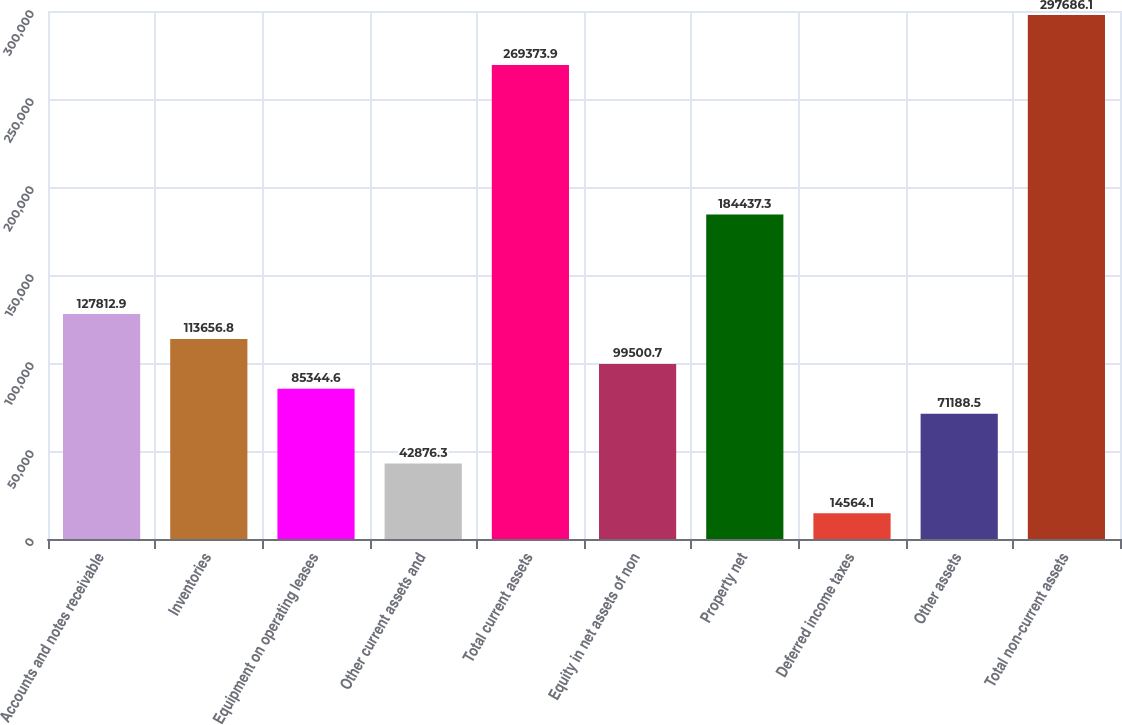<chart> <loc_0><loc_0><loc_500><loc_500><bar_chart><fcel>Accounts and notes receivable<fcel>Inventories<fcel>Equipment on operating leases<fcel>Other current assets and<fcel>Total current assets<fcel>Equity in net assets of non<fcel>Property net<fcel>Deferred income taxes<fcel>Other assets<fcel>Total non-current assets<nl><fcel>127813<fcel>113657<fcel>85344.6<fcel>42876.3<fcel>269374<fcel>99500.7<fcel>184437<fcel>14564.1<fcel>71188.5<fcel>297686<nl></chart> 